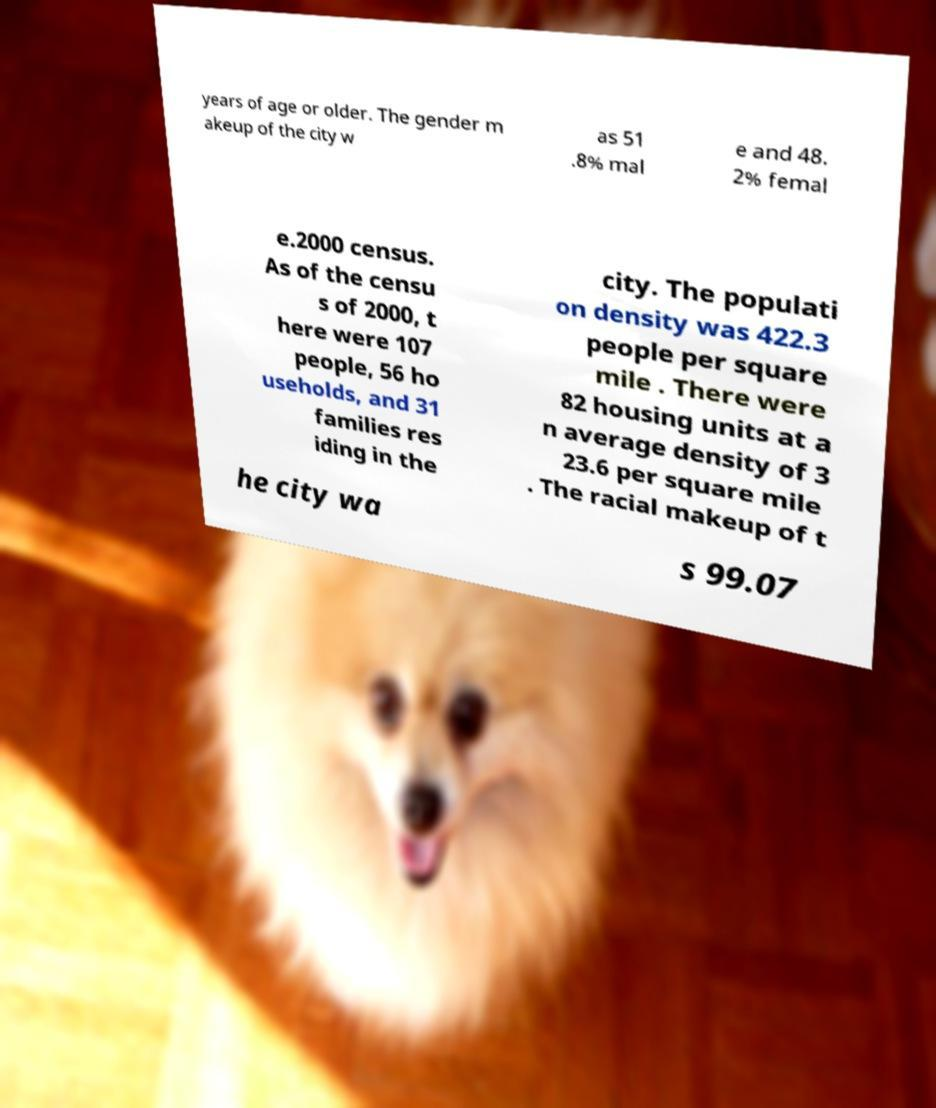Could you extract and type out the text from this image? years of age or older. The gender m akeup of the city w as 51 .8% mal e and 48. 2% femal e.2000 census. As of the censu s of 2000, t here were 107 people, 56 ho useholds, and 31 families res iding in the city. The populati on density was 422.3 people per square mile . There were 82 housing units at a n average density of 3 23.6 per square mile . The racial makeup of t he city wa s 99.07 